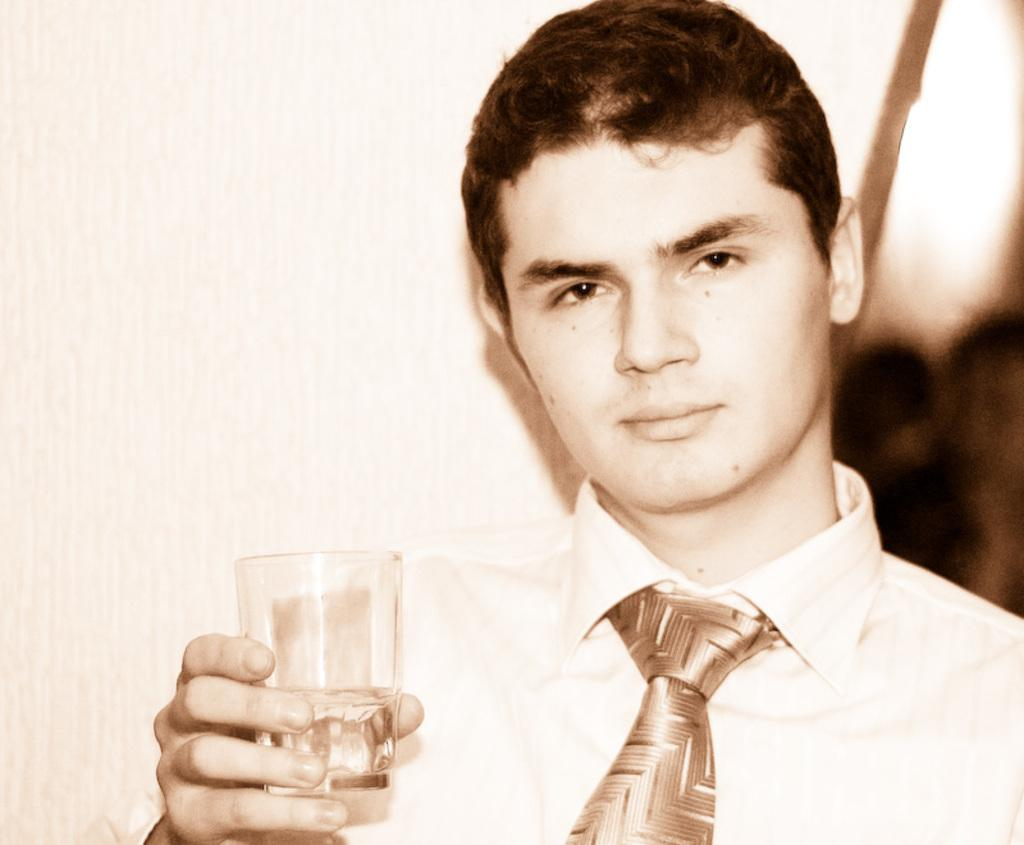Who is present in the image? There is a man in the image. What is the man holding in the image? The man is holding a glass. What can be seen in the background of the image? There is a wall in the background of the image. What type of food is the man eating in the image? There is no food present in the image; the man is holding a glass. How many knots are visible in the image? There are no knots present in the image. 